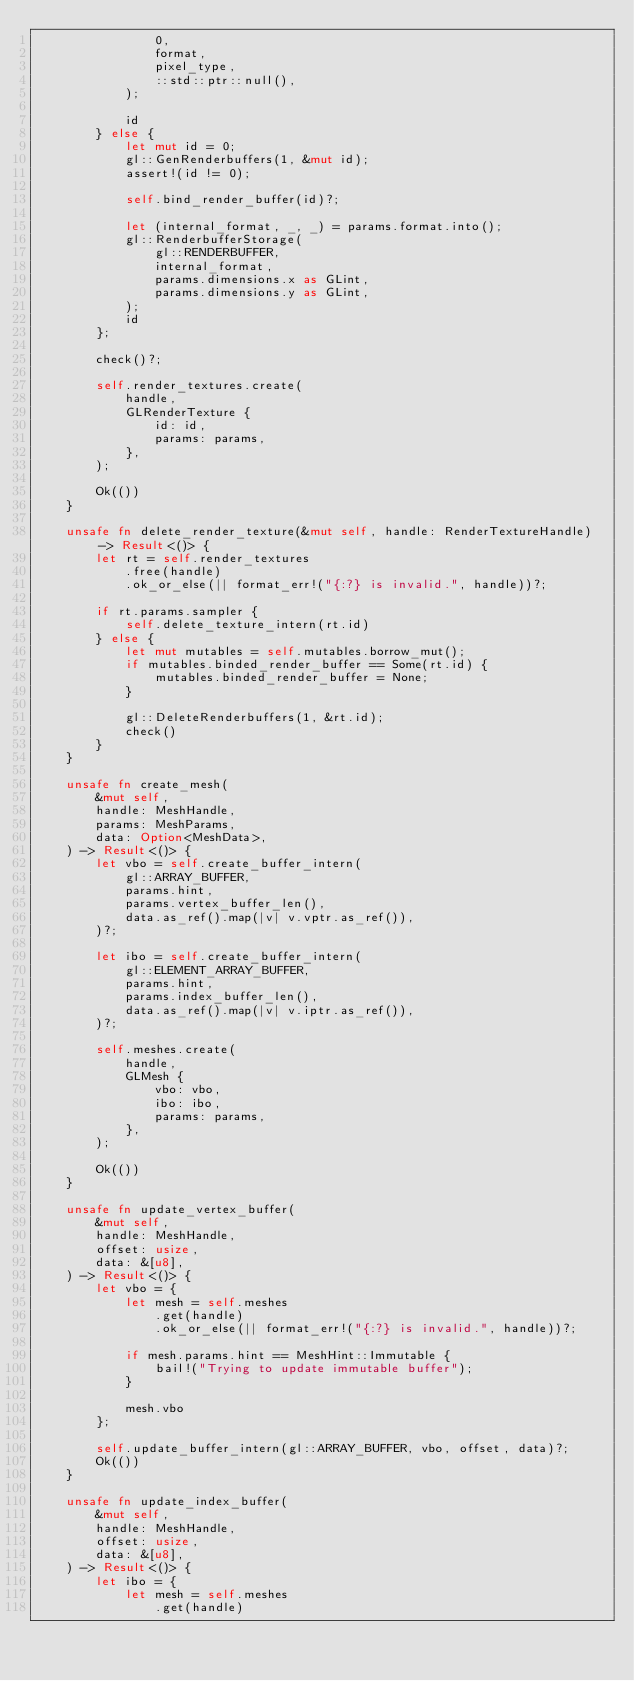<code> <loc_0><loc_0><loc_500><loc_500><_Rust_>                0,
                format,
                pixel_type,
                ::std::ptr::null(),
            );

            id
        } else {
            let mut id = 0;
            gl::GenRenderbuffers(1, &mut id);
            assert!(id != 0);

            self.bind_render_buffer(id)?;

            let (internal_format, _, _) = params.format.into();
            gl::RenderbufferStorage(
                gl::RENDERBUFFER,
                internal_format,
                params.dimensions.x as GLint,
                params.dimensions.y as GLint,
            );
            id
        };

        check()?;

        self.render_textures.create(
            handle,
            GLRenderTexture {
                id: id,
                params: params,
            },
        );

        Ok(())
    }

    unsafe fn delete_render_texture(&mut self, handle: RenderTextureHandle) -> Result<()> {
        let rt = self.render_textures
            .free(handle)
            .ok_or_else(|| format_err!("{:?} is invalid.", handle))?;

        if rt.params.sampler {
            self.delete_texture_intern(rt.id)
        } else {
            let mut mutables = self.mutables.borrow_mut();
            if mutables.binded_render_buffer == Some(rt.id) {
                mutables.binded_render_buffer = None;
            }

            gl::DeleteRenderbuffers(1, &rt.id);
            check()
        }
    }

    unsafe fn create_mesh(
        &mut self,
        handle: MeshHandle,
        params: MeshParams,
        data: Option<MeshData>,
    ) -> Result<()> {
        let vbo = self.create_buffer_intern(
            gl::ARRAY_BUFFER,
            params.hint,
            params.vertex_buffer_len(),
            data.as_ref().map(|v| v.vptr.as_ref()),
        )?;

        let ibo = self.create_buffer_intern(
            gl::ELEMENT_ARRAY_BUFFER,
            params.hint,
            params.index_buffer_len(),
            data.as_ref().map(|v| v.iptr.as_ref()),
        )?;

        self.meshes.create(
            handle,
            GLMesh {
                vbo: vbo,
                ibo: ibo,
                params: params,
            },
        );

        Ok(())
    }

    unsafe fn update_vertex_buffer(
        &mut self,
        handle: MeshHandle,
        offset: usize,
        data: &[u8],
    ) -> Result<()> {
        let vbo = {
            let mesh = self.meshes
                .get(handle)
                .ok_or_else(|| format_err!("{:?} is invalid.", handle))?;

            if mesh.params.hint == MeshHint::Immutable {
                bail!("Trying to update immutable buffer");
            }

            mesh.vbo
        };

        self.update_buffer_intern(gl::ARRAY_BUFFER, vbo, offset, data)?;
        Ok(())
    }

    unsafe fn update_index_buffer(
        &mut self,
        handle: MeshHandle,
        offset: usize,
        data: &[u8],
    ) -> Result<()> {
        let ibo = {
            let mesh = self.meshes
                .get(handle)</code> 